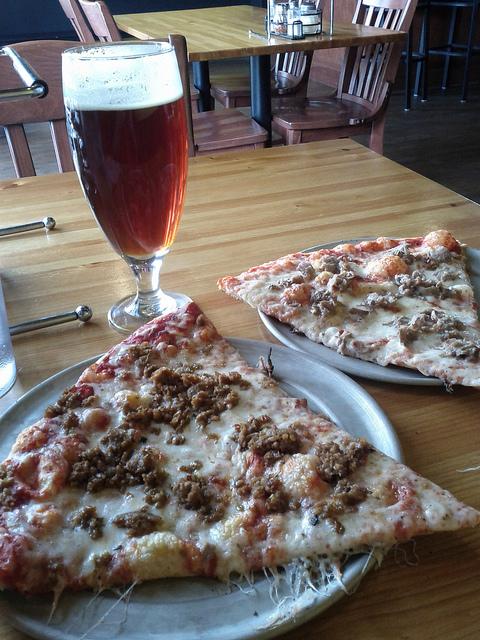Does the table have a tablecloth on it?
Write a very short answer. No. Does this place serve alcohol?
Short answer required. Yes. How many plates are on the table?
Concise answer only. 2. 